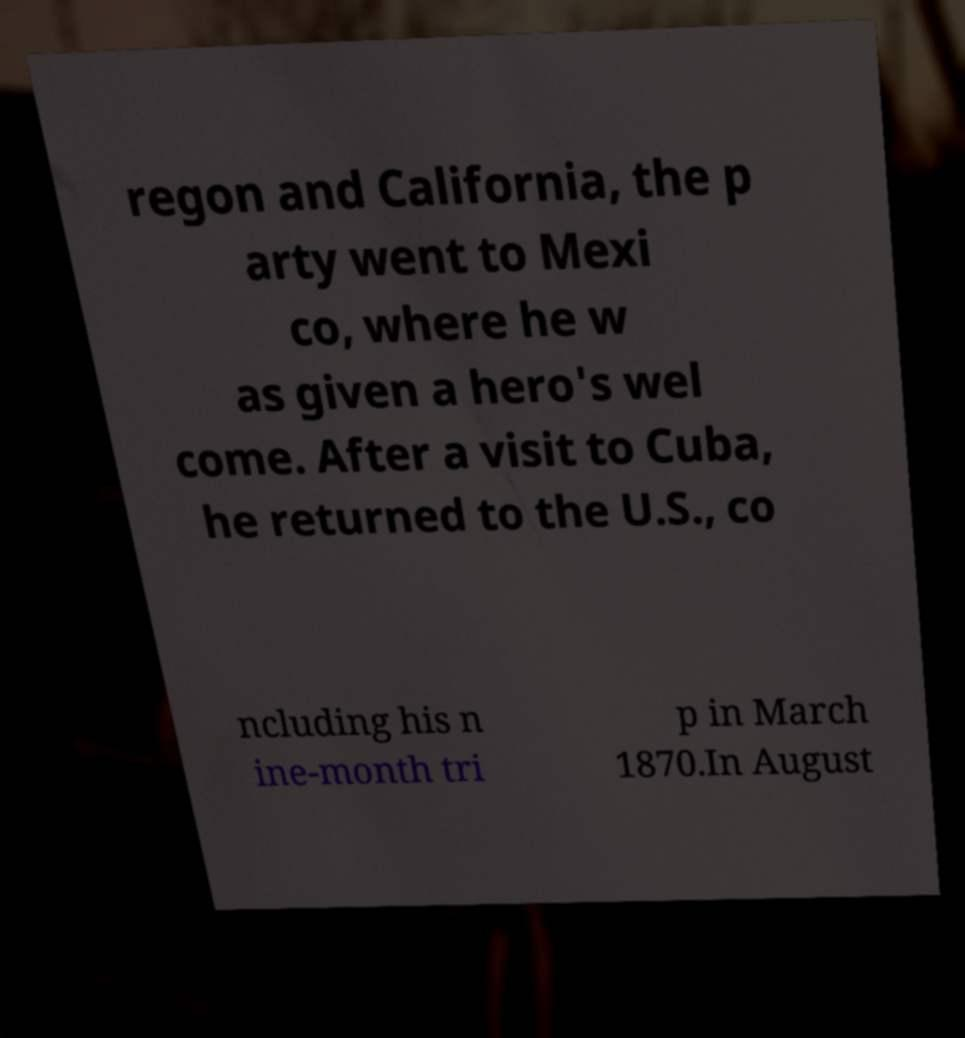For documentation purposes, I need the text within this image transcribed. Could you provide that? regon and California, the p arty went to Mexi co, where he w as given a hero's wel come. After a visit to Cuba, he returned to the U.S., co ncluding his n ine-month tri p in March 1870.In August 